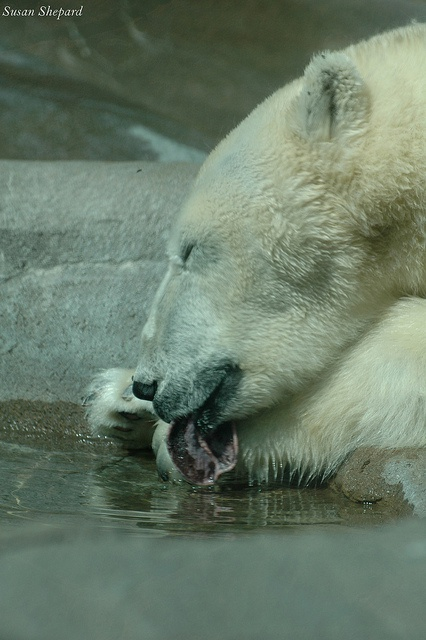Describe the objects in this image and their specific colors. I can see a bear in black, darkgray, gray, and beige tones in this image. 